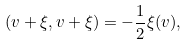<formula> <loc_0><loc_0><loc_500><loc_500>( v + \xi , v + \xi ) = - \frac { 1 } { 2 } \xi ( v ) ,</formula> 